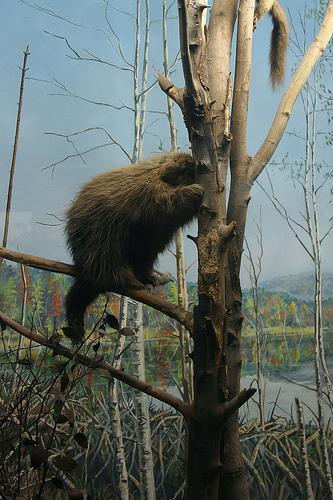Question: why are the trees bare?
Choices:
A. The leaves have fallen.
B. It's winter.
C. They trees are dead.
D. It is cold.
Answer with the letter. Answer: A Question: what is dull blue?
Choices:
A. The ocean.
B. The clock.
C. The sweater.
D. The sky.
Answer with the letter. Answer: D 